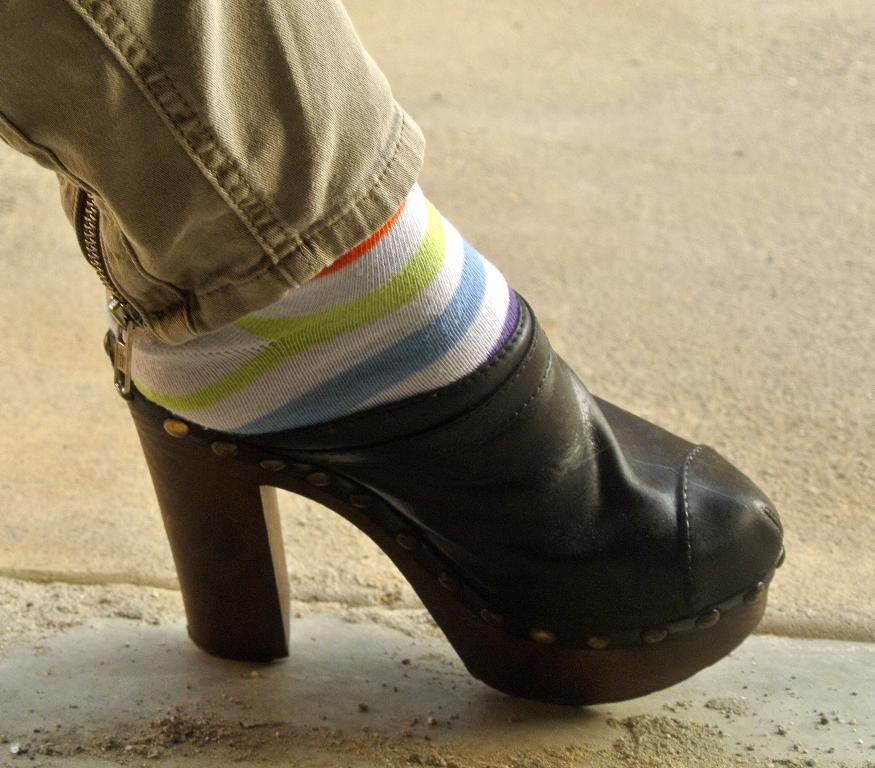What part of a person's body is visible in the image? There is a person's leg in the image. What is covering the person's foot in the image? The leg has a shoe on it. What is covering the person's leg between the skin and the shoe? The leg has a sock on it. What can be seen behind the leg in the image? There is a surface in the background of the image. Can you see the person's tongue in the image? There is no tongue visible in the image; only a leg with a shoe and a sock is present. 